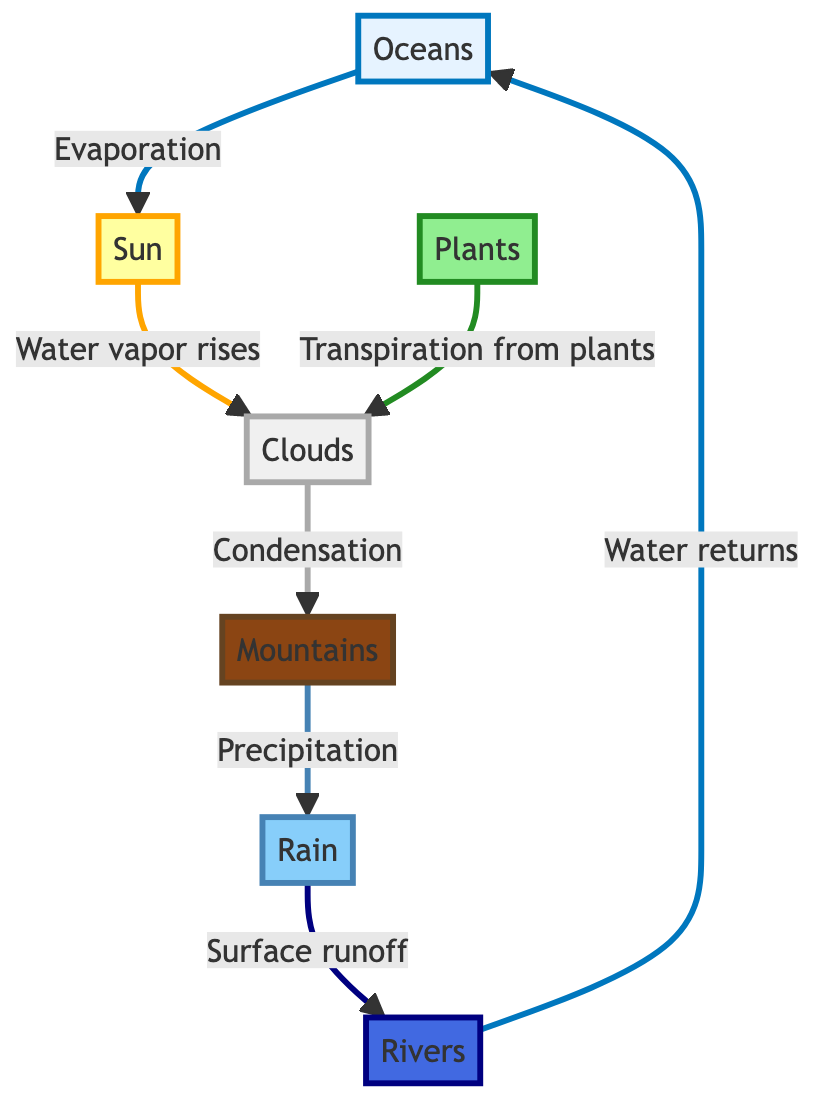What is the starting point of the water cycle in this diagram? The diagram indicates that the water cycle begins with "Oceans," as it is the first node listed.
Answer: Oceans What follows evaporation in the water cycle? Following evaporation, the next action in the diagram is "Water vapor rises," which connects the "Sun" to "Clouds."
Answer: Water vapor rises How many main components are represented in this diagram? Counting the nodes, there are seven main components in the water cycle diagram: Oceans, Sun, Clouds, Mountains, Rain, Rivers, and Plants.
Answer: Seven What process is indicated between clouds and mountains? The diagram shows "Condensation" as the process that occurs between "Clouds" and "Mountains."
Answer: Condensation What happens after precipitation according to the flow? After "Precipitation," the diagram illustrates that "Surface runoff" occurs, leading to the next component, "Rivers."
Answer: Surface runoff Which component contributes to clouds other than evaporation? The diagram specifies "Transpiration from plants," as another process contributing to the formation of clouds.
Answer: Transpiration from plants Which two components are interconnected by surface runoff? The components "Rain" and "Rivers" are connected by the process of "Surface runoff," indicating how water travels after precipitation.
Answer: Rain and Rivers What is the final step for the water in the rivers? The diagram indicates that the final step for water in the rivers is to return to the "Oceans," completing the cycle.
Answer: Water returns Which process connects plants to clouds? The process that connects "Plants" to "Clouds" is indicated as "Transpiration from plants" in the diagram.
Answer: Transpiration from plants What role does the sun play in the water cycle according to the diagram? The "Sun" initiates the water cycle by causing "Evaporation" from the oceans, demonstrating its role in the process.
Answer: Evaporation 